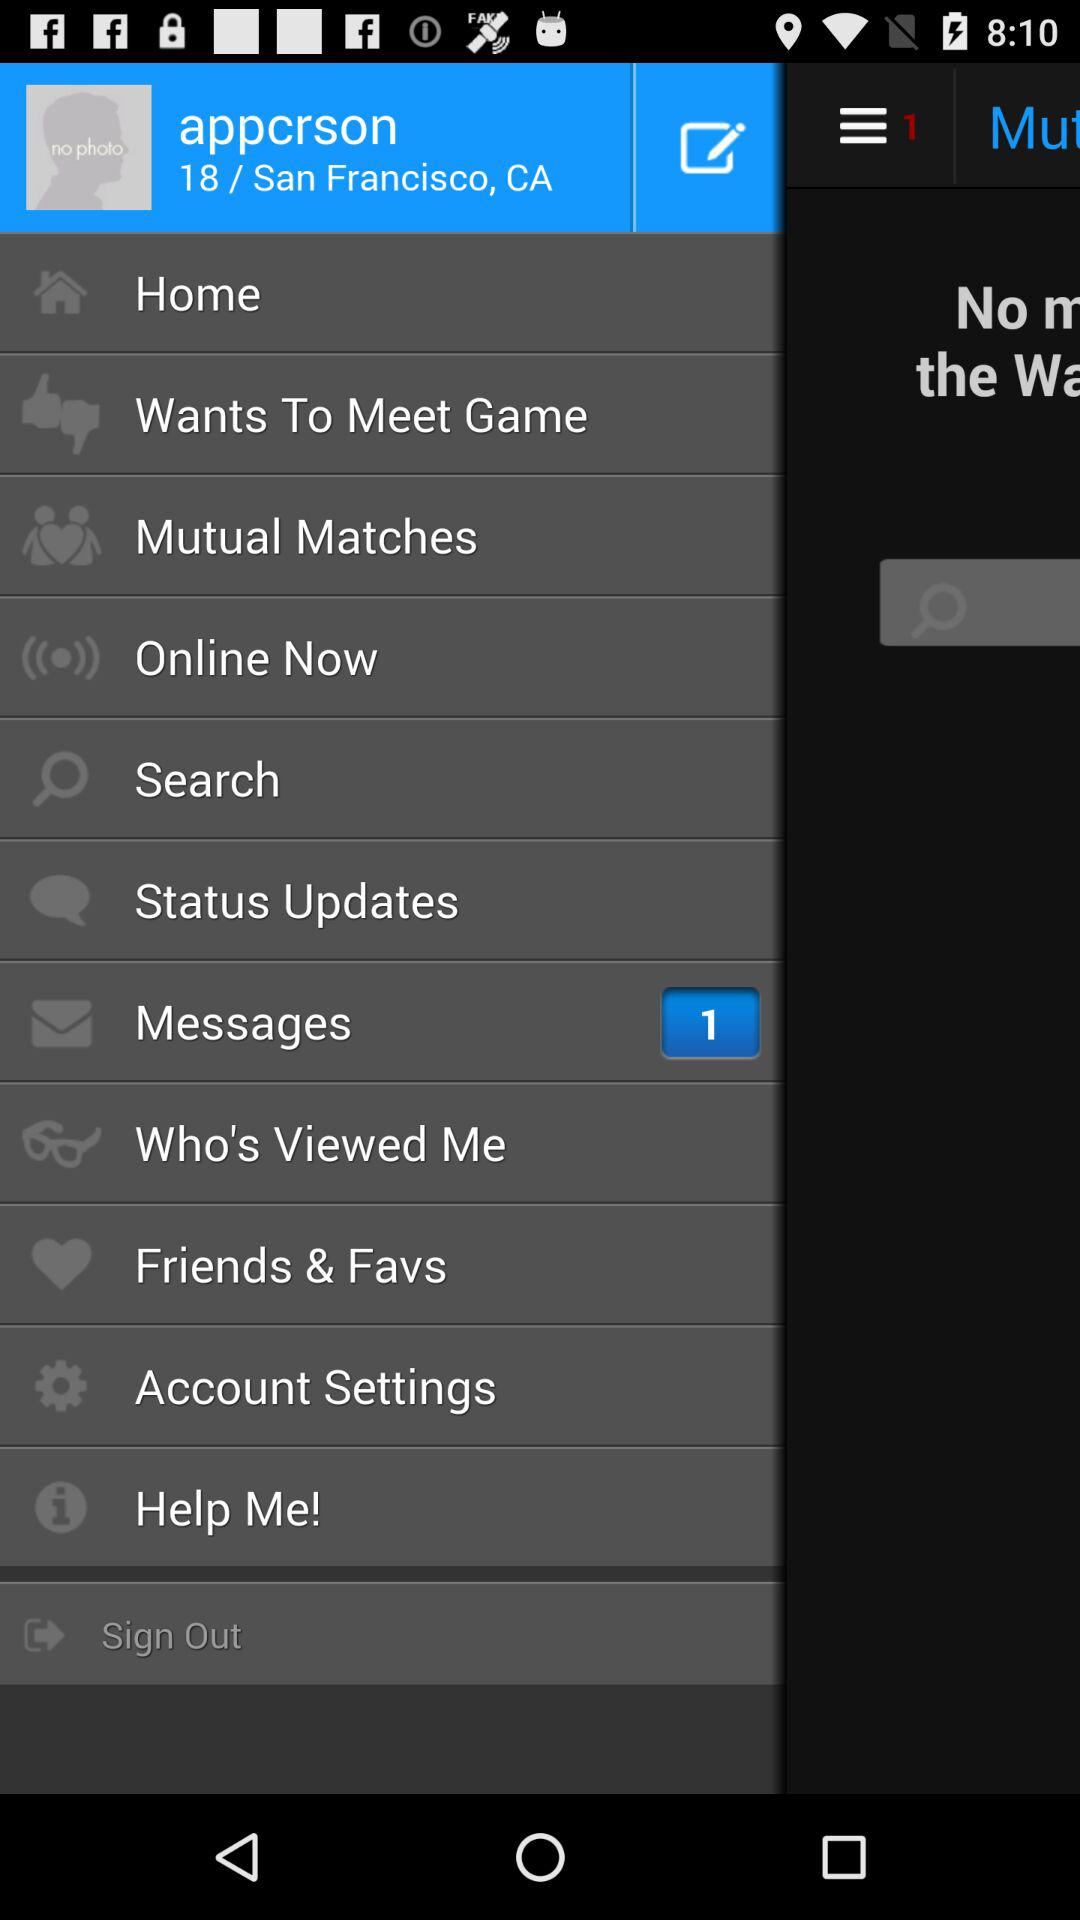What is the status of "Mutual Matches"?
When the provided information is insufficient, respond with <no answer>. <no answer> 